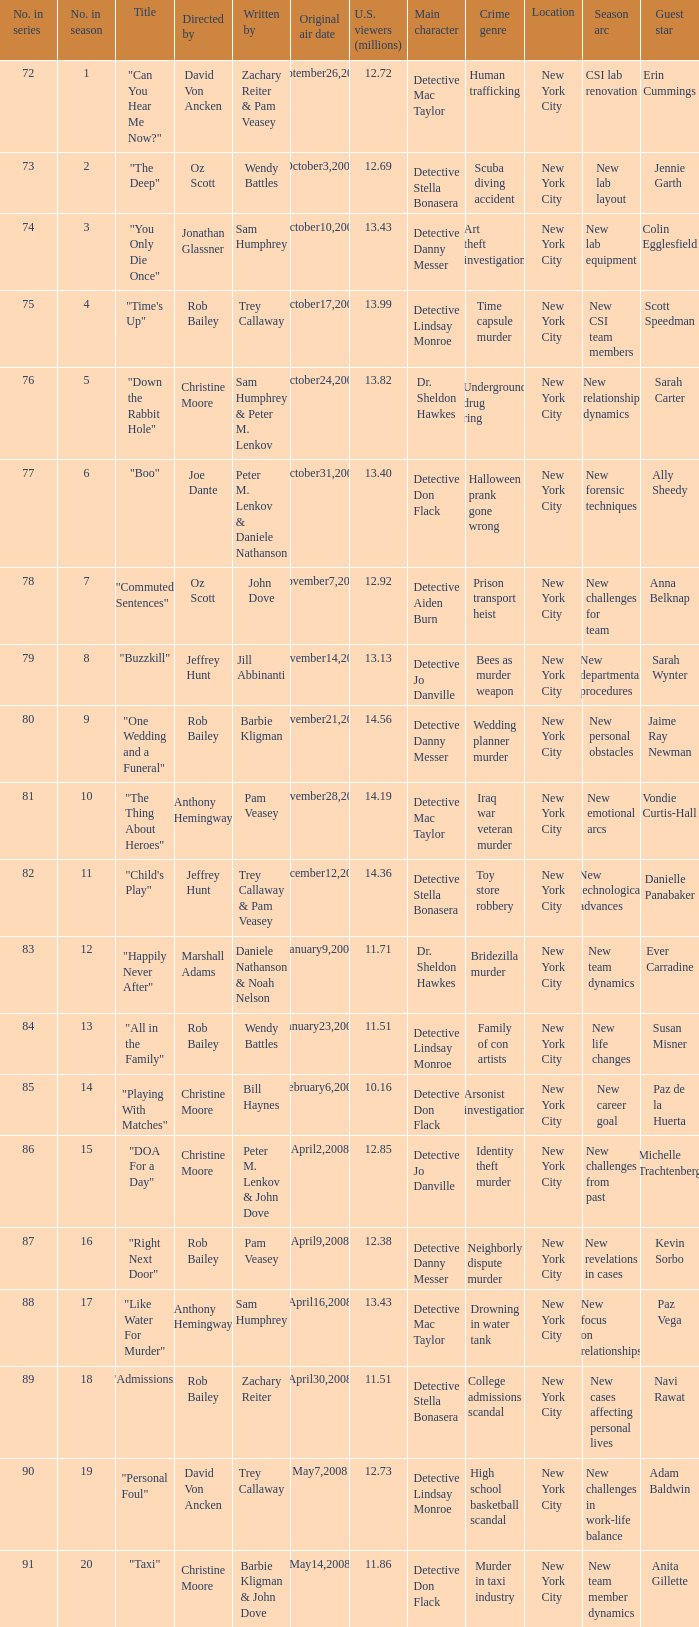How many millions of U.S. viewers watched the episode directed by Rob Bailey and written by Pam Veasey? 12.38. 